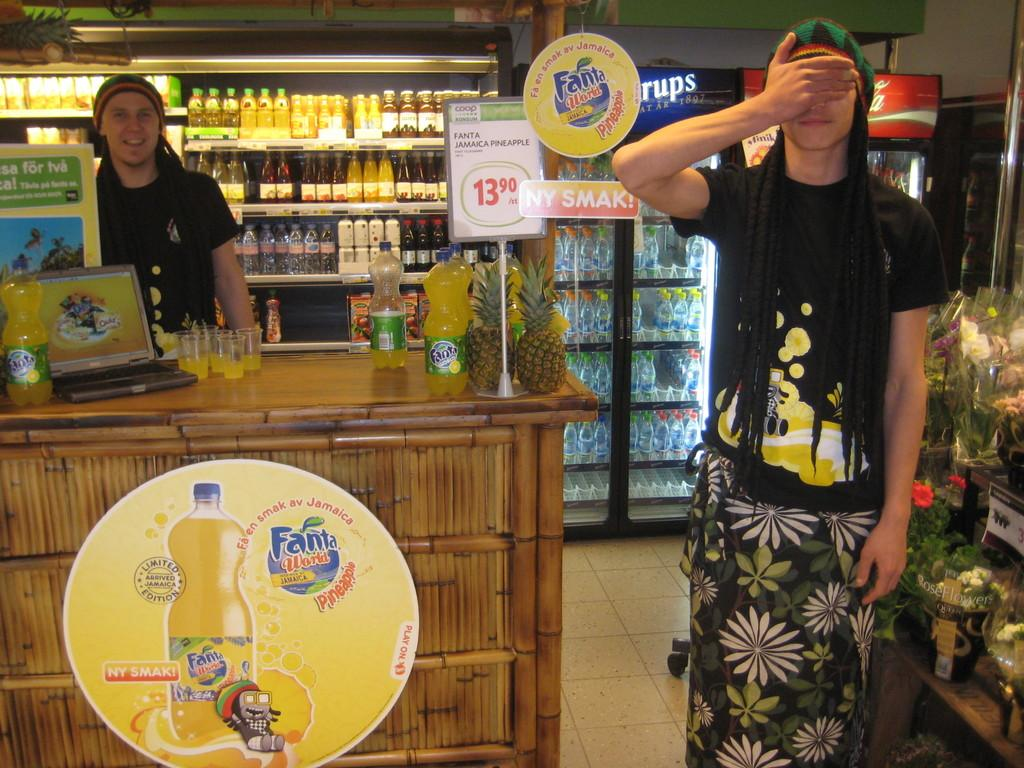<image>
Share a concise interpretation of the image provided. Two clerks in dreadlocks working at a Hawaiian-themed stand with Fanta featured on the counter. 